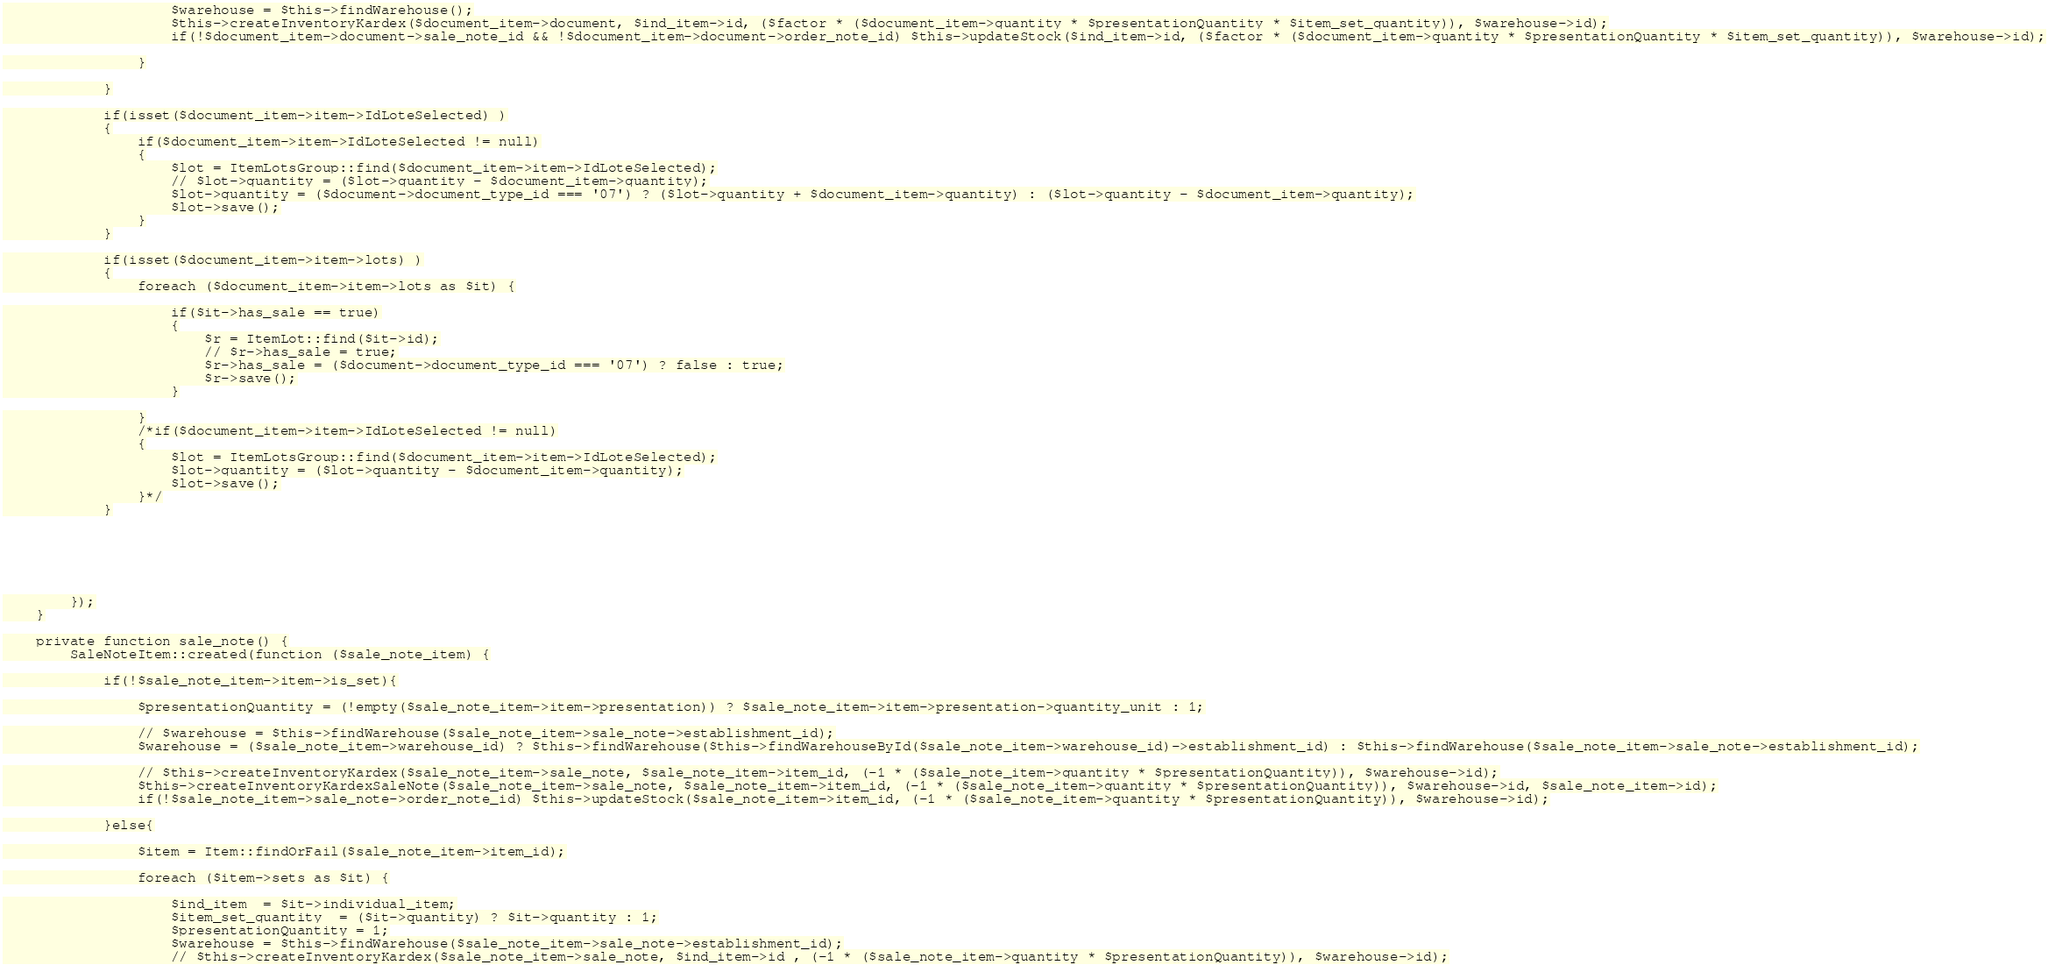Convert code to text. <code><loc_0><loc_0><loc_500><loc_500><_PHP_>                    $warehouse = $this->findWarehouse();
                    $this->createInventoryKardex($document_item->document, $ind_item->id, ($factor * ($document_item->quantity * $presentationQuantity * $item_set_quantity)), $warehouse->id);
                    if(!$document_item->document->sale_note_id && !$document_item->document->order_note_id) $this->updateStock($ind_item->id, ($factor * ($document_item->quantity * $presentationQuantity * $item_set_quantity)), $warehouse->id);

                }

            }

            if(isset($document_item->item->IdLoteSelected) )
            {
                if($document_item->item->IdLoteSelected != null)
                {
                    $lot = ItemLotsGroup::find($document_item->item->IdLoteSelected);
                    // $lot->quantity = ($lot->quantity - $document_item->quantity);
                    $lot->quantity = ($document->document_type_id === '07') ? ($lot->quantity + $document_item->quantity) : ($lot->quantity - $document_item->quantity);
                    $lot->save();
                }
            }

            if(isset($document_item->item->lots) )
            {
                foreach ($document_item->item->lots as $it) {

                    if($it->has_sale == true)
                    {
                        $r = ItemLot::find($it->id);
                        // $r->has_sale = true;
                        $r->has_sale = ($document->document_type_id === '07') ? false : true;
                        $r->save();
                    }

                }
                /*if($document_item->item->IdLoteSelected != null)
                {
                    $lot = ItemLotsGroup::find($document_item->item->IdLoteSelected);
                    $lot->quantity = ($lot->quantity - $document_item->quantity);
                    $lot->save();
                }*/
            }






        });
    }

    private function sale_note() {
        SaleNoteItem::created(function ($sale_note_item) {

            if(!$sale_note_item->item->is_set){

                $presentationQuantity = (!empty($sale_note_item->item->presentation)) ? $sale_note_item->item->presentation->quantity_unit : 1;

                // $warehouse = $this->findWarehouse($sale_note_item->sale_note->establishment_id);
                $warehouse = ($sale_note_item->warehouse_id) ? $this->findWarehouse($this->findWarehouseById($sale_note_item->warehouse_id)->establishment_id) : $this->findWarehouse($sale_note_item->sale_note->establishment_id);

                // $this->createInventoryKardex($sale_note_item->sale_note, $sale_note_item->item_id, (-1 * ($sale_note_item->quantity * $presentationQuantity)), $warehouse->id);
                $this->createInventoryKardexSaleNote($sale_note_item->sale_note, $sale_note_item->item_id, (-1 * ($sale_note_item->quantity * $presentationQuantity)), $warehouse->id, $sale_note_item->id);
                if(!$sale_note_item->sale_note->order_note_id) $this->updateStock($sale_note_item->item_id, (-1 * ($sale_note_item->quantity * $presentationQuantity)), $warehouse->id);

            }else{

                $item = Item::findOrFail($sale_note_item->item_id);

                foreach ($item->sets as $it) {

                    $ind_item  = $it->individual_item;
                    $item_set_quantity  = ($it->quantity) ? $it->quantity : 1;
                    $presentationQuantity = 1;
                    $warehouse = $this->findWarehouse($sale_note_item->sale_note->establishment_id);
                    // $this->createInventoryKardex($sale_note_item->sale_note, $ind_item->id , (-1 * ($sale_note_item->quantity * $presentationQuantity)), $warehouse->id);</code> 